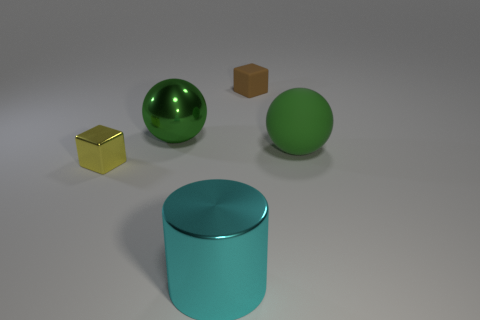Add 3 big cyan shiny cylinders. How many objects exist? 8 Subtract all cubes. How many objects are left? 3 Subtract 1 spheres. How many spheres are left? 1 Subtract all gray cylinders. Subtract all metallic things. How many objects are left? 2 Add 4 big matte objects. How many big matte objects are left? 5 Add 2 metal balls. How many metal balls exist? 3 Subtract all brown cubes. How many cubes are left? 1 Subtract 0 purple cylinders. How many objects are left? 5 Subtract all purple balls. Subtract all cyan blocks. How many balls are left? 2 